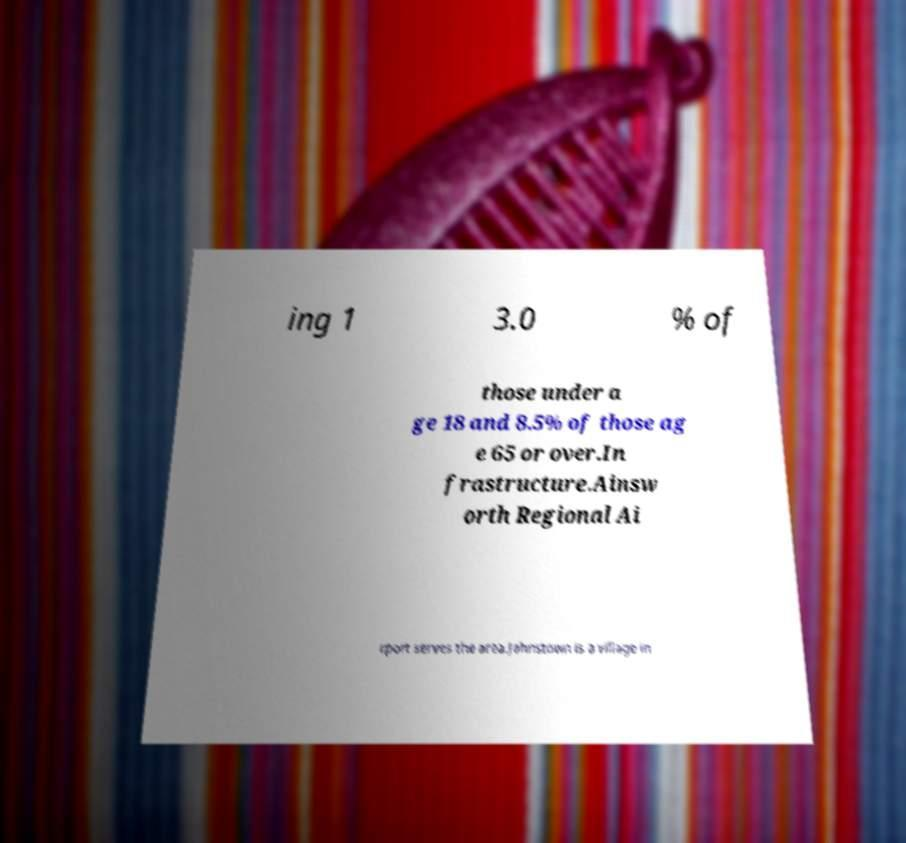Please identify and transcribe the text found in this image. ing 1 3.0 % of those under a ge 18 and 8.5% of those ag e 65 or over.In frastructure.Ainsw orth Regional Ai rport serves the area.Johnstown is a village in 